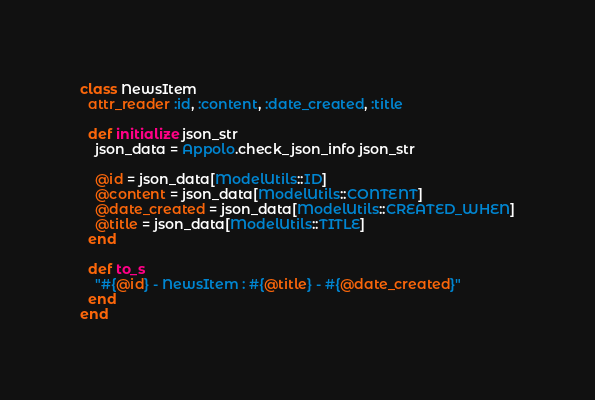<code> <loc_0><loc_0><loc_500><loc_500><_Ruby_>
class NewsItem
  attr_reader :id, :content, :date_created, :title

  def initialize json_str
    json_data = Appolo.check_json_info json_str
  
    @id = json_data[ModelUtils::ID]
    @content = json_data[ModelUtils::CONTENT]
    @date_created = json_data[ModelUtils::CREATED_WHEN]
    @title = json_data[ModelUtils::TITLE]
  end

  def to_s
    "#{@id} - NewsItem : #{@title} - #{@date_created}"
  end
end</code> 